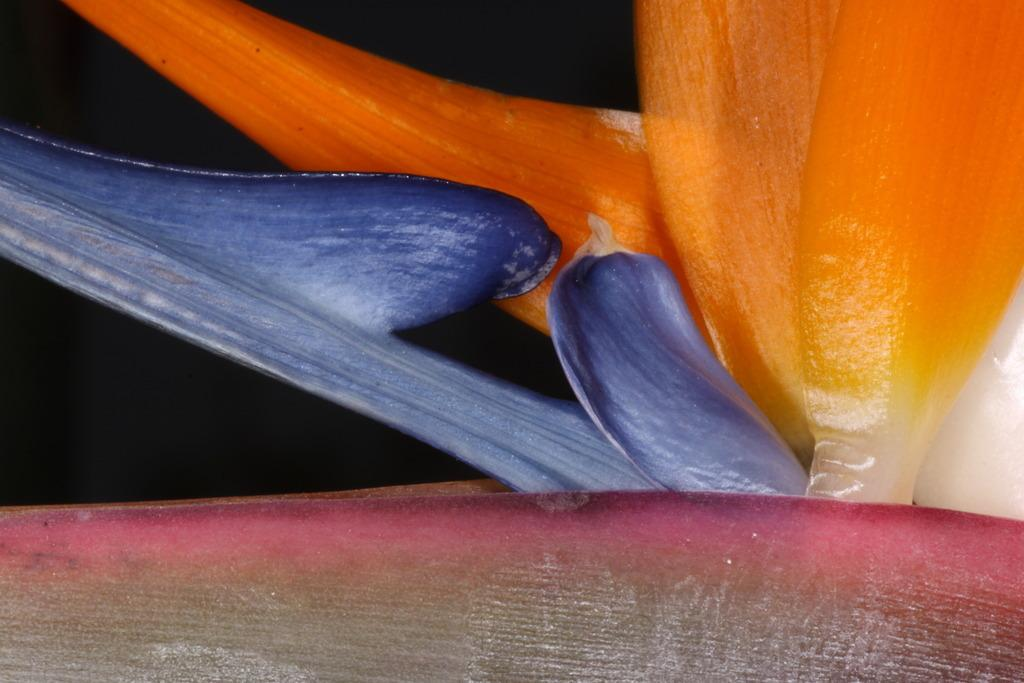What type of natural elements can be seen in the image? There are petals of flowers in the image. Can you describe the texture or appearance of the petals? The texture or appearance of the petals cannot be determined from the image alone. What might be the color of the flowers based on the petals shown? The color of the flowers cannot be determined from the image alone, as only the petals are visible. What type of whip can be seen in the image? There is no whip present in the image; it features petals of flowers. 